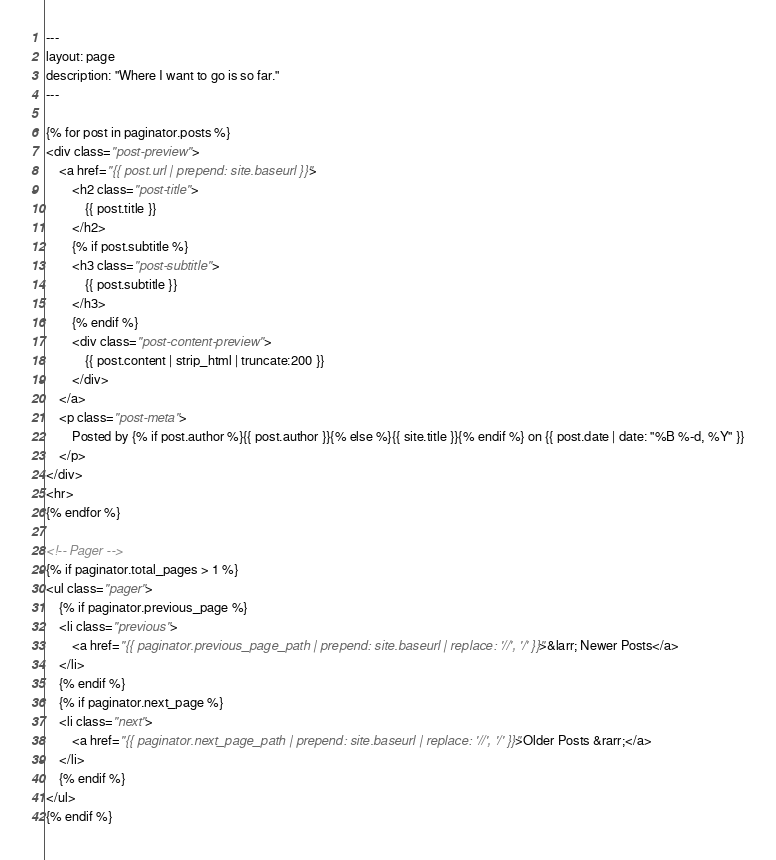<code> <loc_0><loc_0><loc_500><loc_500><_HTML_>---
layout: page
description: "Where I want to go is so far."
---

{% for post in paginator.posts %}
<div class="post-preview">
    <a href="{{ post.url | prepend: site.baseurl }}">
        <h2 class="post-title">
            {{ post.title }}
        </h2>
        {% if post.subtitle %}
        <h3 class="post-subtitle">
            {{ post.subtitle }}
        </h3>
        {% endif %}
        <div class="post-content-preview">
            {{ post.content | strip_html | truncate:200 }}
        </div>
    </a>
    <p class="post-meta">
        Posted by {% if post.author %}{{ post.author }}{% else %}{{ site.title }}{% endif %} on {{ post.date | date: "%B %-d, %Y" }}
    </p>
</div>
<hr>
{% endfor %}

<!-- Pager -->
{% if paginator.total_pages > 1 %}
<ul class="pager">
    {% if paginator.previous_page %}
    <li class="previous">
        <a href="{{ paginator.previous_page_path | prepend: site.baseurl | replace: '//', '/' }}">&larr; Newer Posts</a>
    </li>
    {% endif %}
    {% if paginator.next_page %}
    <li class="next">
        <a href="{{ paginator.next_page_path | prepend: site.baseurl | replace: '//', '/' }}">Older Posts &rarr;</a>
    </li>
    {% endif %}
</ul>
{% endif %}
</code> 